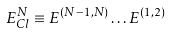<formula> <loc_0><loc_0><loc_500><loc_500>E ^ { N } _ { C l } \equiv E ^ { ( N - 1 , N ) } \dots E ^ { ( 1 , 2 ) }</formula> 